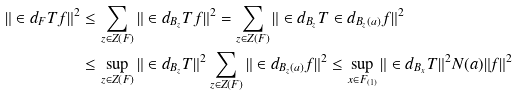Convert formula to latex. <formula><loc_0><loc_0><loc_500><loc_500>\| \in d _ { F } T f \| ^ { 2 } & \leq \sum _ { z \in Z ( F ) } \| \in d _ { B _ { z } } T f \| ^ { 2 } = \sum _ { z \in Z ( F ) } \| \in d _ { B _ { z } } T \in d _ { B _ { z } ( a ) } f \| ^ { 2 } \\ & \leq \sup _ { z \in Z ( F ) } \| \in d _ { B _ { z } } T \| ^ { 2 } \sum _ { z \in Z ( F ) } \| \in d _ { B _ { z } ( a ) } f \| ^ { 2 } \leq \sup _ { x \in F _ { ( 1 ) } } \| \in d _ { B _ { x } } T \| ^ { 2 } N ( a ) \| f \| ^ { 2 }</formula> 